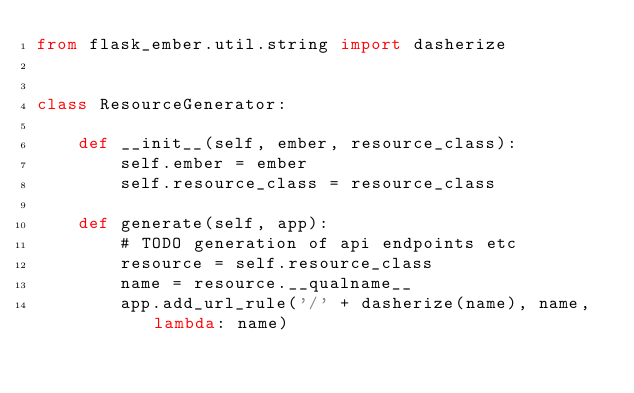<code> <loc_0><loc_0><loc_500><loc_500><_Python_>from flask_ember.util.string import dasherize


class ResourceGenerator:

    def __init__(self, ember, resource_class):
        self.ember = ember
        self.resource_class = resource_class

    def generate(self, app):
        # TODO generation of api endpoints etc
        resource = self.resource_class
        name = resource.__qualname__
        app.add_url_rule('/' + dasherize(name), name, lambda: name)
</code> 